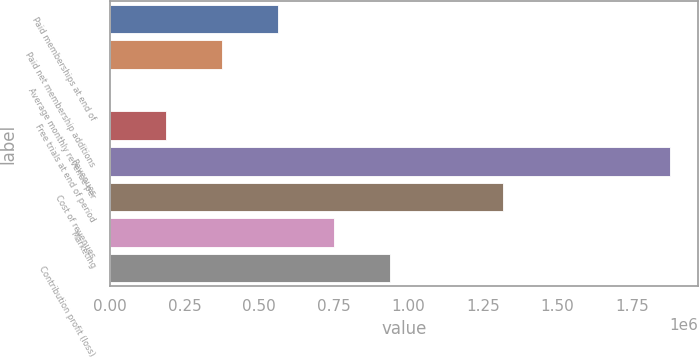Convert chart. <chart><loc_0><loc_0><loc_500><loc_500><bar_chart><fcel>Paid memberships at end of<fcel>Paid net membership additions<fcel>Average monthly revenue per<fcel>Free trials at end of period<fcel>Revenues<fcel>Cost of revenues<fcel>Marketing<fcel>Contribution profit (loss)<nl><fcel>563429<fcel>375620<fcel>0.85<fcel>187810<fcel>1.8781e+06<fcel>1.31687e+06<fcel>751239<fcel>939048<nl></chart> 